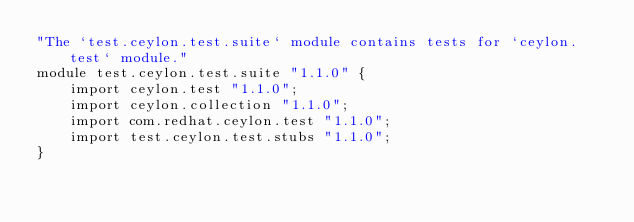Convert code to text. <code><loc_0><loc_0><loc_500><loc_500><_Ceylon_>"The `test.ceylon.test.suite` module contains tests for `ceylon.test` module."
module test.ceylon.test.suite "1.1.0" {
    import ceylon.test "1.1.0";
    import ceylon.collection "1.1.0";
    import com.redhat.ceylon.test "1.1.0";
    import test.ceylon.test.stubs "1.1.0";
}</code> 